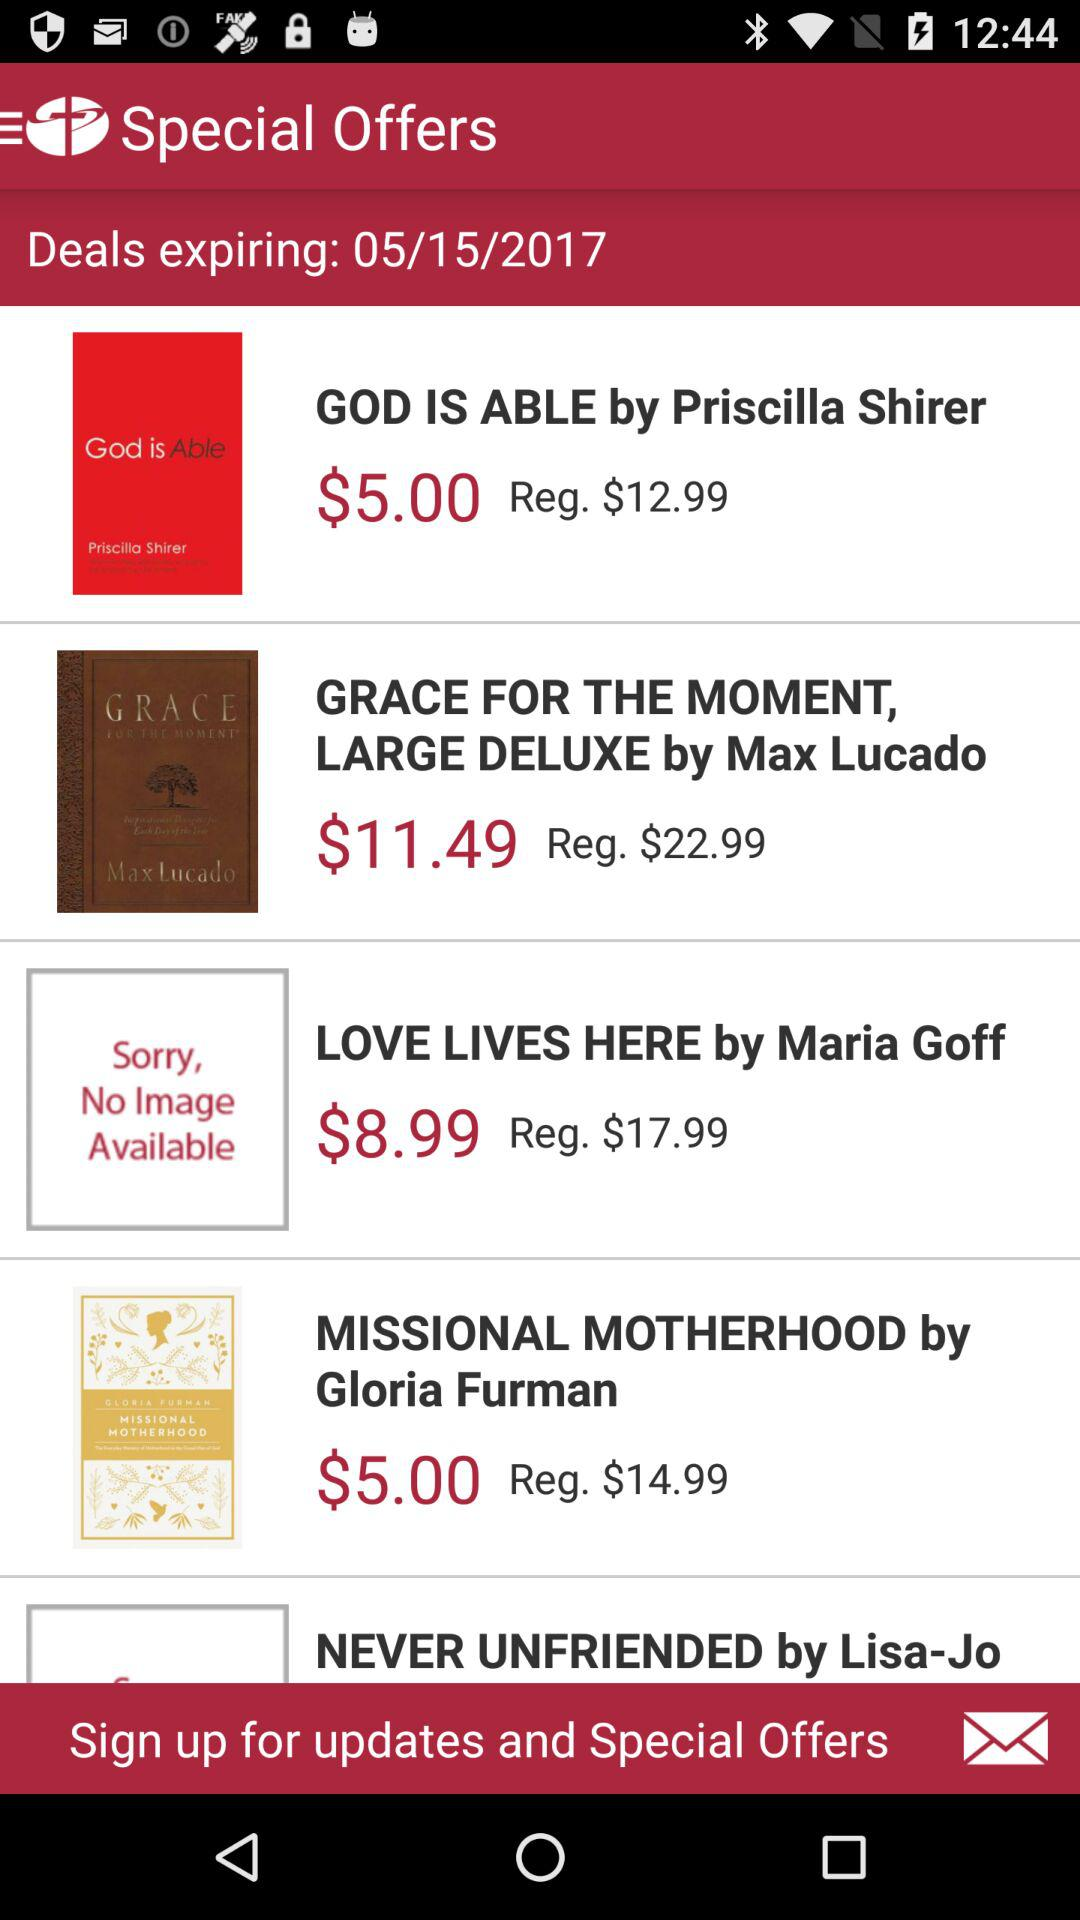On what date will the deals expire? The deals will expire on May 15, 2017. 